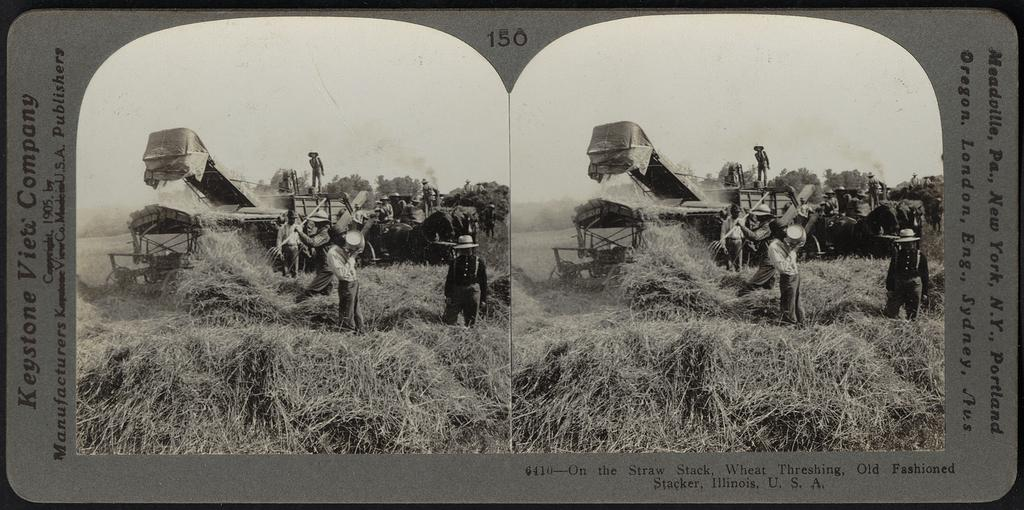Provide a one-sentence caption for the provided image. An old black and white picture captioned Keystone Viete Company. 